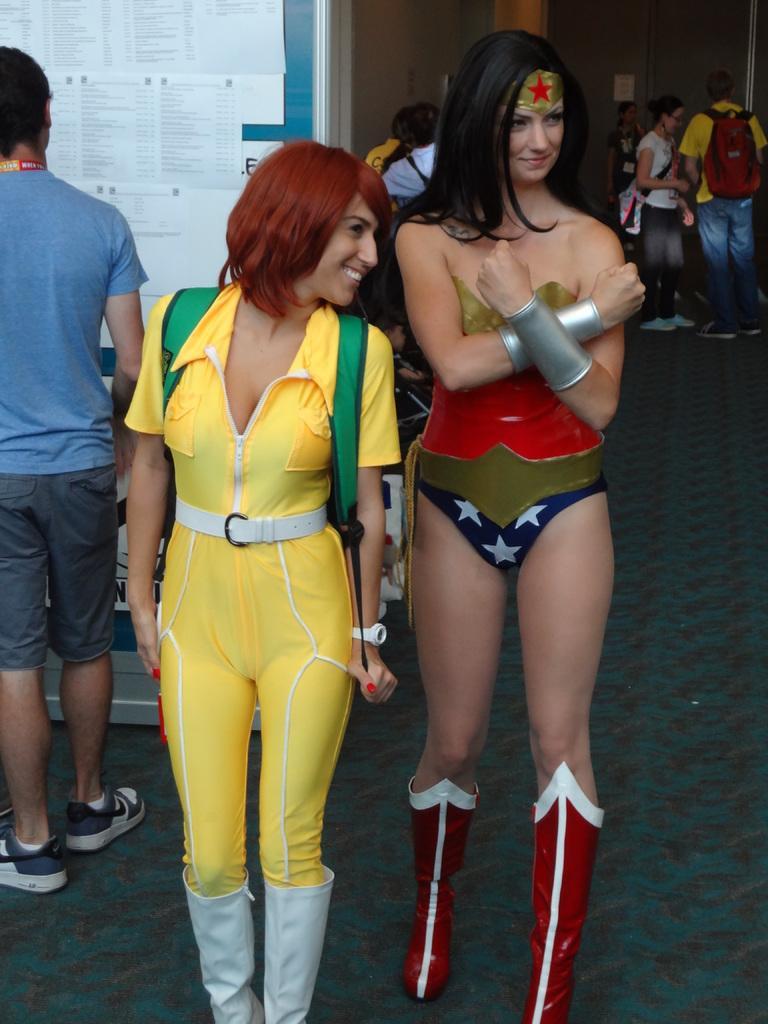Please provide a concise description of this image. In this image, I can see the woman standing and smiling. She wore a fancy dress. I can see groups of people standing. These are the papers, which are attached to a notice board. This is the floor. 